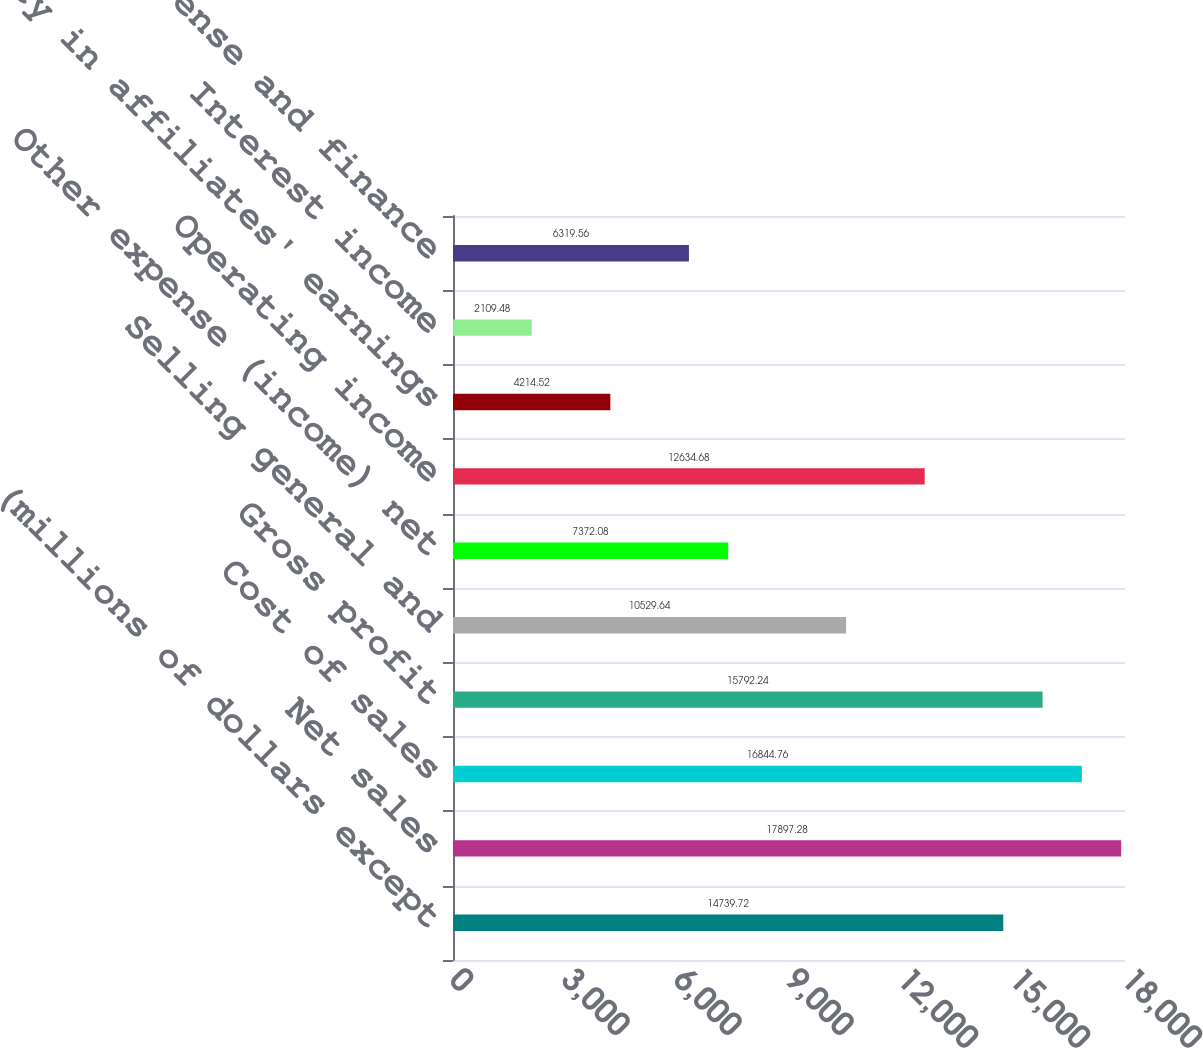Convert chart to OTSL. <chart><loc_0><loc_0><loc_500><loc_500><bar_chart><fcel>(millions of dollars except<fcel>Net sales<fcel>Cost of sales<fcel>Gross profit<fcel>Selling general and<fcel>Other expense (income) net<fcel>Operating income<fcel>Equity in affiliates' earnings<fcel>Interest income<fcel>Interest expense and finance<nl><fcel>14739.7<fcel>17897.3<fcel>16844.8<fcel>15792.2<fcel>10529.6<fcel>7372.08<fcel>12634.7<fcel>4214.52<fcel>2109.48<fcel>6319.56<nl></chart> 